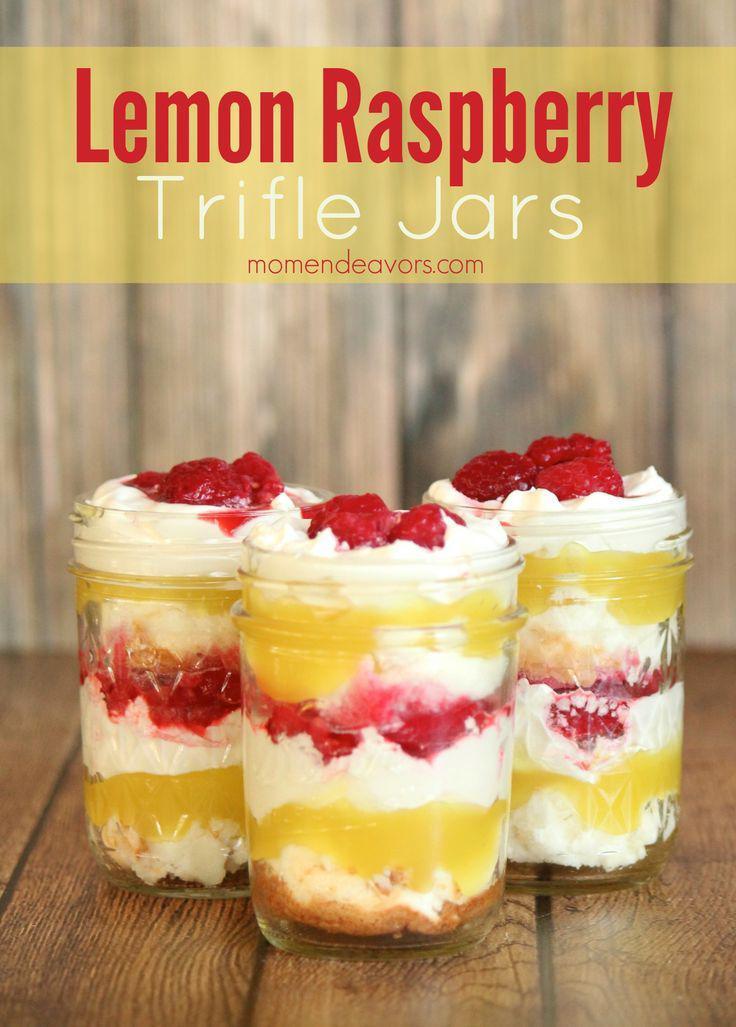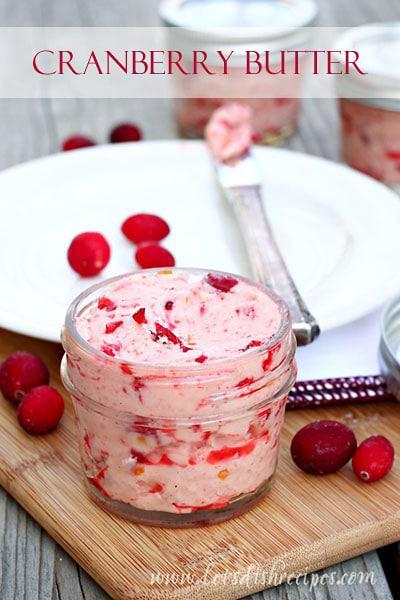The first image is the image on the left, the second image is the image on the right. For the images displayed, is the sentence "The dessert on the left does not contain any berries." factually correct? Answer yes or no. No. The first image is the image on the left, the second image is the image on the right. Evaluate the accuracy of this statement regarding the images: "An image shows a layered dessert served in a footed glass.". Is it true? Answer yes or no. No. 